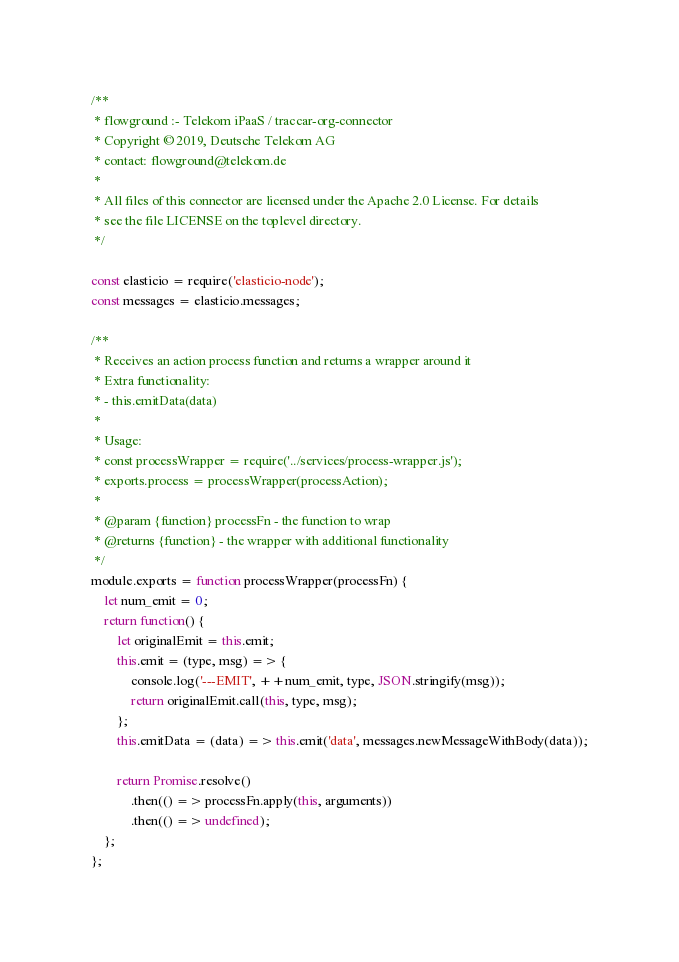<code> <loc_0><loc_0><loc_500><loc_500><_JavaScript_>/**
 * flowground :- Telekom iPaaS / traccar-org-connector
 * Copyright © 2019, Deutsche Telekom AG
 * contact: flowground@telekom.de
 *
 * All files of this connector are licensed under the Apache 2.0 License. For details
 * see the file LICENSE on the toplevel directory.
 */

const elasticio = require('elasticio-node');
const messages = elasticio.messages;

/**
 * Receives an action process function and returns a wrapper around it
 * Extra functionality:
 * - this.emitData(data)
 *
 * Usage:
 * const processWrapper = require('../services/process-wrapper.js');
 * exports.process = processWrapper(processAction);
 *
 * @param {function} processFn - the function to wrap
 * @returns {function} - the wrapper with additional functionality
 */
module.exports = function processWrapper(processFn) {
    let num_emit = 0;
    return function() {
        let originalEmit = this.emit;
        this.emit = (type, msg) => {
            console.log('---EMIT', ++num_emit, type, JSON.stringify(msg));
            return originalEmit.call(this, type, msg);
        };
        this.emitData = (data) => this.emit('data', messages.newMessageWithBody(data));

        return Promise.resolve()
            .then(() => processFn.apply(this, arguments))
            .then(() => undefined);
    };
};</code> 